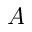<formula> <loc_0><loc_0><loc_500><loc_500>A</formula> 